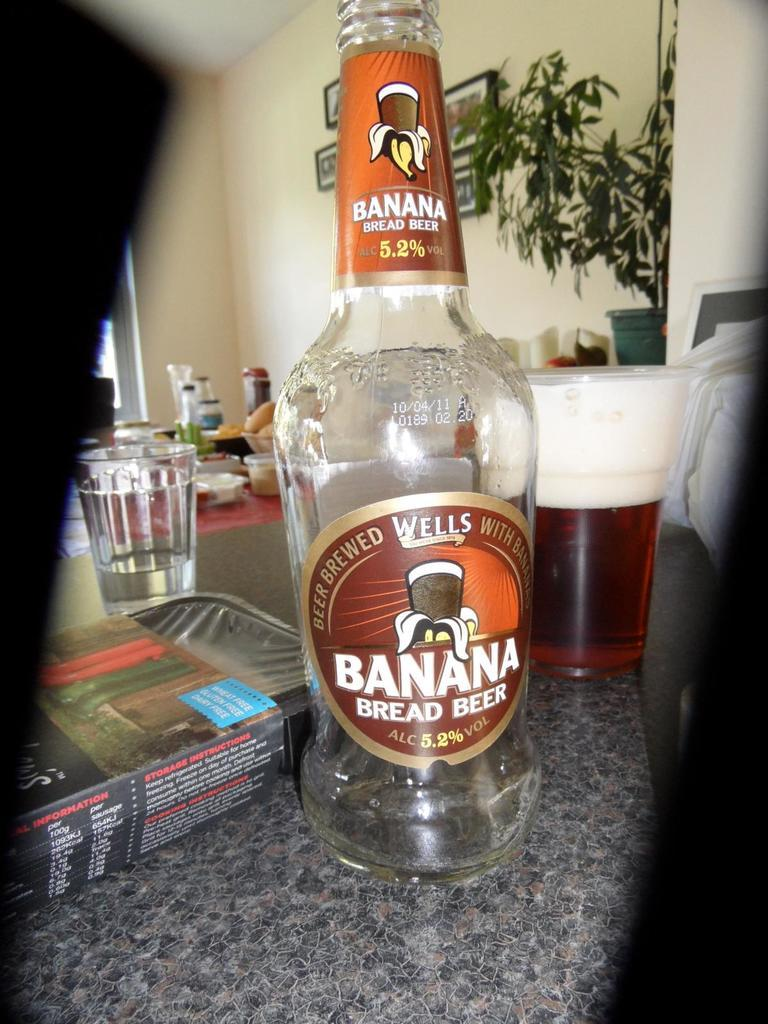<image>
Give a short and clear explanation of the subsequent image. An empty bottle of Banana Bread beer sits on a table next to a full glass. 